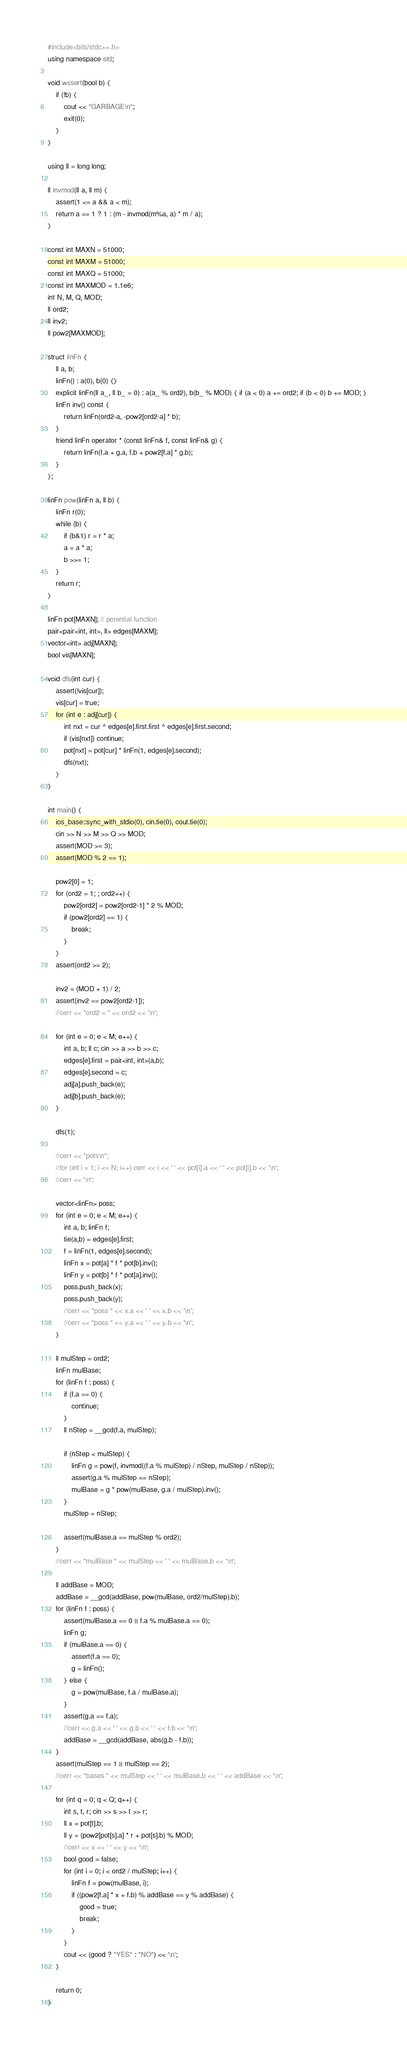<code> <loc_0><loc_0><loc_500><loc_500><_C++_>#include<bits/stdc++.h>
using namespace std;

void wssert(bool b) {
	if (!b) {
		cout << "GARBAGE\n";
		exit(0);
	}
}

using ll = long long;

ll invmod(ll a, ll m) {
	assert(1 <= a && a < m);
	return a == 1 ? 1 : (m - invmod(m%a, a) * m / a);
}

const int MAXN = 51000;
const int MAXM = 51000;
const int MAXQ = 51000;
const int MAXMOD = 1.1e6;
int N, M, Q, MOD;
ll ord2;
ll inv2;
ll pow2[MAXMOD];

struct linFn {
	ll a, b;
	linFn() : a(0), b(0) {}
	explicit linFn(ll a_, ll b_ = 0) : a(a_ % ord2), b(b_ % MOD) { if (a < 0) a += ord2; if (b < 0) b += MOD; }
	linFn inv() const {
		return linFn(ord2-a, -pow2[ord2-a] * b);
	}
	friend linFn operator * (const linFn& f, const linFn& g) {
		return linFn(f.a + g.a, f.b + pow2[f.a] * g.b);
	}
};

linFn pow(linFn a, ll b) {
	linFn r(0);
	while (b) {
		if (b&1) r = r * a;
		a = a * a;
		b >>= 1;
	}
	return r;
}

linFn pot[MAXN]; // potential function
pair<pair<int, int>, ll> edges[MAXM];
vector<int> adj[MAXN];
bool vis[MAXN];

void dfs(int cur) {
	assert(!vis[cur]);
	vis[cur] = true;
	for (int e : adj[cur]) {
		int nxt = cur ^ edges[e].first.first ^ edges[e].first.second;
		if (vis[nxt]) continue;
		pot[nxt] = pot[cur] * linFn(1, edges[e].second);
		dfs(nxt);
	}
}

int main() {
	ios_base::sync_with_stdio(0), cin.tie(0), cout.tie(0);
	cin >> N >> M >> Q >> MOD;
	assert(MOD >= 3);
	assert(MOD % 2 == 1);

	pow2[0] = 1;
	for (ord2 = 1; ; ord2++) {
		pow2[ord2] = pow2[ord2-1] * 2 % MOD;
		if (pow2[ord2] == 1) {
			break;
		}
	}
	assert(ord2 >= 2);

	inv2 = (MOD + 1) / 2;
	assert(inv2 == pow2[ord2-1]);
	//cerr << "ord2 = " << ord2 << '\n';

	for (int e = 0; e < M; e++) {
		int a, b; ll c; cin >> a >> b >> c;
		edges[e].first = pair<int, int>(a,b);
		edges[e].second = c;
		adj[a].push_back(e);
		adj[b].push_back(e);
	}

	dfs(1);

	//cerr << "pots\n";
	//for (int i = 1; i <= N; i++) cerr << i << ' ' << pot[i].a << ' ' << pot[i].b << '\n';
	//cerr << '\n';

	vector<linFn> poss;
	for (int e = 0; e < M; e++) {
		int a, b; linFn f;
		tie(a,b) = edges[e].first;
		f = linFn(1, edges[e].second);
		linFn x = pot[a] * f * pot[b].inv();
		linFn y = pot[b] * f * pot[a].inv();
		poss.push_back(x);
		poss.push_back(y);
		//cerr << "poss " << x.a << ' ' << x.b << '\n';
		//cerr << "poss " << y.a << ' ' << y.b << '\n';
	}

	ll mulStep = ord2;
	linFn mulBase;
	for (linFn f : poss) {
		if (f.a == 0) {
			continue;
		}
		ll nStep = __gcd(f.a, mulStep);

		if (nStep < mulStep) {
			linFn g = pow(f, invmod((f.a % mulStep) / nStep, mulStep / nStep));
			assert(g.a % mulStep == nStep);
			mulBase = g * pow(mulBase, g.a / mulStep).inv();
		}
		mulStep = nStep;

		assert(mulBase.a == mulStep % ord2);
	}
	//cerr << "mulBase " << mulStep << ' ' << mulBase.b << '\n';

	ll addBase = MOD;
	addBase = __gcd(addBase, pow(mulBase, ord2/mulStep).b);
	for (linFn f : poss) {
		assert(mulBase.a == 0 || f.a % mulBase.a == 0);
		linFn g;
		if (mulBase.a == 0) {
			assert(f.a == 0);
			g = linFn();
		} else {
			g = pow(mulBase, f.a / mulBase.a);
		}
		assert(g.a == f.a);
		//cerr << g.a << ' ' << g.b << ' ' << f.b << '\n';
		addBase = __gcd(addBase, abs(g.b - f.b));
	}
	assert(mulStep == 1 || mulStep == 2);
	//cerr << "bases " << mulStep << ' ' << mulBase.b << ' ' << addBase << '\n';

	for (int q = 0; q < Q; q++) {
		int s, t, r; cin >> s >> t >> r;
		ll x = pot[t].b;
		ll y = (pow2[pot[s].a] * r + pot[s].b) % MOD;
		//cerr << x << ' ' << y << '\n';
		bool good = false;
		for (int i = 0; i < ord2 / mulStep; i++) {
			linFn f = pow(mulBase, i);
			if ((pow2[f.a] * x + f.b) % addBase == y % addBase) {
				good = true;
				break;
			}
		}
		cout << (good ? "YES" : "NO") << '\n';
	}

	return 0;
}
</code> 